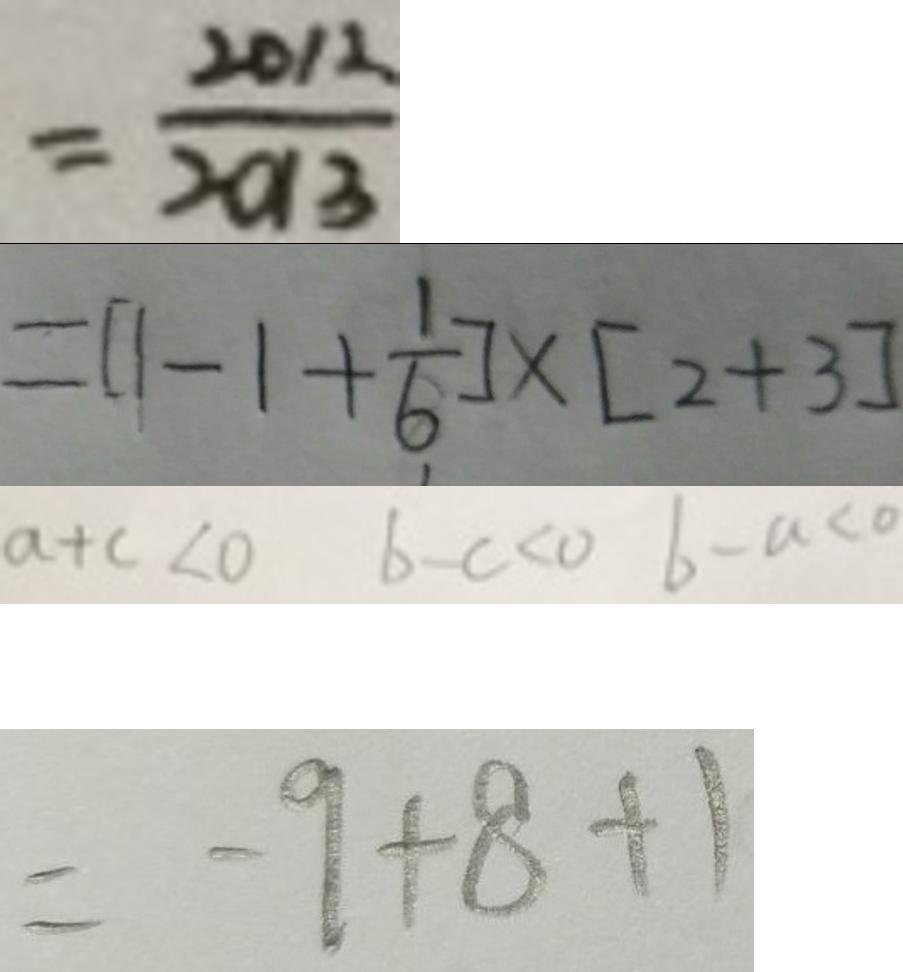<formula> <loc_0><loc_0><loc_500><loc_500>= \frac { 2 0 1 2 } { 2 0 1 3 } 
 = [ 1 - 1 + \frac { 1 } { 6 } ] \times [ 2 + 3 ] 
 a + c < 0 b - c < 0 b - a < 0 
 = - 9 + 8 + 1</formula> 